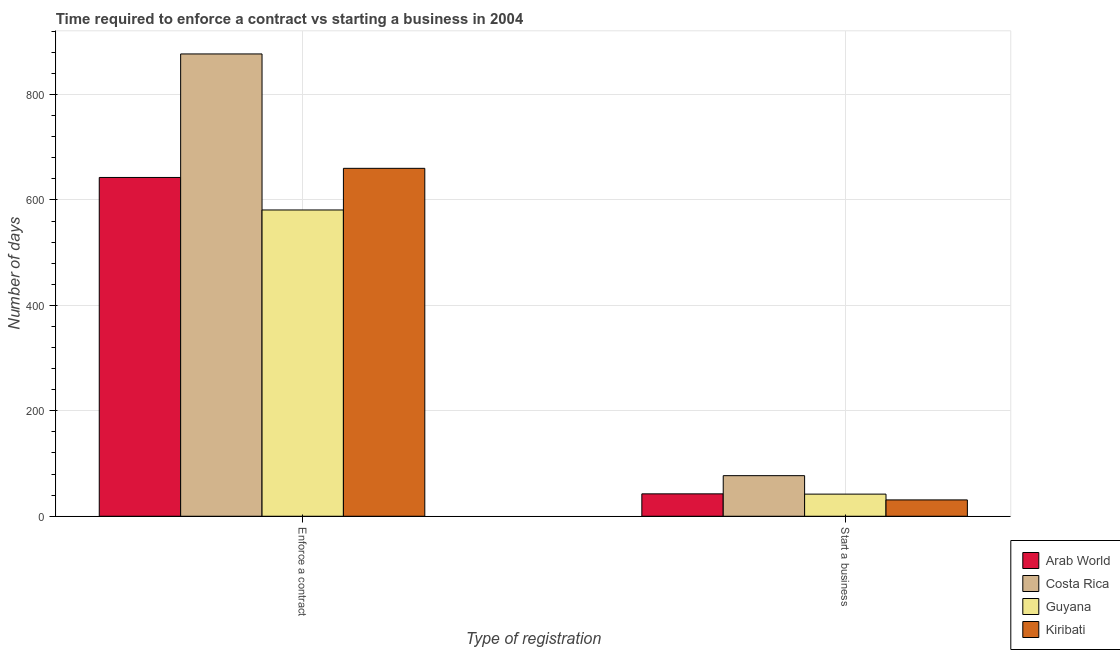How many different coloured bars are there?
Provide a short and direct response. 4. How many groups of bars are there?
Your response must be concise. 2. How many bars are there on the 1st tick from the right?
Your answer should be very brief. 4. What is the label of the 2nd group of bars from the left?
Offer a very short reply. Start a business. In which country was the number of days to enforece a contract maximum?
Your answer should be very brief. Costa Rica. In which country was the number of days to enforece a contract minimum?
Offer a terse response. Guyana. What is the total number of days to start a business in the graph?
Offer a terse response. 192.5. What is the difference between the number of days to enforece a contract in Guyana and that in Arab World?
Keep it short and to the point. -61.69. What is the difference between the number of days to enforece a contract in Costa Rica and the number of days to start a business in Arab World?
Make the answer very short. 834.5. What is the average number of days to start a business per country?
Keep it short and to the point. 48.12. What is the difference between the number of days to enforece a contract and number of days to start a business in Costa Rica?
Ensure brevity in your answer.  800. In how many countries, is the number of days to enforece a contract greater than 320 days?
Make the answer very short. 4. What is the ratio of the number of days to start a business in Kiribati to that in Costa Rica?
Keep it short and to the point. 0.4. What does the 2nd bar from the left in Enforce a contract represents?
Your answer should be compact. Costa Rica. What does the 4th bar from the right in Enforce a contract represents?
Make the answer very short. Arab World. How many bars are there?
Keep it short and to the point. 8. Are all the bars in the graph horizontal?
Your answer should be very brief. No. How many countries are there in the graph?
Offer a very short reply. 4. Are the values on the major ticks of Y-axis written in scientific E-notation?
Give a very brief answer. No. Does the graph contain any zero values?
Offer a very short reply. No. Does the graph contain grids?
Keep it short and to the point. Yes. Where does the legend appear in the graph?
Provide a succinct answer. Bottom right. What is the title of the graph?
Ensure brevity in your answer.  Time required to enforce a contract vs starting a business in 2004. What is the label or title of the X-axis?
Offer a very short reply. Type of registration. What is the label or title of the Y-axis?
Ensure brevity in your answer.  Number of days. What is the Number of days in Arab World in Enforce a contract?
Keep it short and to the point. 642.69. What is the Number of days of Costa Rica in Enforce a contract?
Your answer should be very brief. 877. What is the Number of days of Guyana in Enforce a contract?
Offer a terse response. 581. What is the Number of days in Kiribati in Enforce a contract?
Your answer should be compact. 660. What is the Number of days in Arab World in Start a business?
Ensure brevity in your answer.  42.5. What is the Number of days of Kiribati in Start a business?
Make the answer very short. 31. Across all Type of registration, what is the maximum Number of days of Arab World?
Offer a very short reply. 642.69. Across all Type of registration, what is the maximum Number of days of Costa Rica?
Ensure brevity in your answer.  877. Across all Type of registration, what is the maximum Number of days of Guyana?
Offer a very short reply. 581. Across all Type of registration, what is the maximum Number of days in Kiribati?
Keep it short and to the point. 660. Across all Type of registration, what is the minimum Number of days of Arab World?
Give a very brief answer. 42.5. Across all Type of registration, what is the minimum Number of days of Kiribati?
Give a very brief answer. 31. What is the total Number of days of Arab World in the graph?
Give a very brief answer. 685.19. What is the total Number of days in Costa Rica in the graph?
Provide a succinct answer. 954. What is the total Number of days of Guyana in the graph?
Your response must be concise. 623. What is the total Number of days of Kiribati in the graph?
Keep it short and to the point. 691. What is the difference between the Number of days in Arab World in Enforce a contract and that in Start a business?
Make the answer very short. 600.19. What is the difference between the Number of days in Costa Rica in Enforce a contract and that in Start a business?
Give a very brief answer. 800. What is the difference between the Number of days of Guyana in Enforce a contract and that in Start a business?
Make the answer very short. 539. What is the difference between the Number of days of Kiribati in Enforce a contract and that in Start a business?
Offer a very short reply. 629. What is the difference between the Number of days in Arab World in Enforce a contract and the Number of days in Costa Rica in Start a business?
Your answer should be compact. 565.69. What is the difference between the Number of days in Arab World in Enforce a contract and the Number of days in Guyana in Start a business?
Your response must be concise. 600.69. What is the difference between the Number of days of Arab World in Enforce a contract and the Number of days of Kiribati in Start a business?
Your response must be concise. 611.69. What is the difference between the Number of days of Costa Rica in Enforce a contract and the Number of days of Guyana in Start a business?
Provide a succinct answer. 835. What is the difference between the Number of days in Costa Rica in Enforce a contract and the Number of days in Kiribati in Start a business?
Your answer should be very brief. 846. What is the difference between the Number of days in Guyana in Enforce a contract and the Number of days in Kiribati in Start a business?
Make the answer very short. 550. What is the average Number of days of Arab World per Type of registration?
Make the answer very short. 342.59. What is the average Number of days of Costa Rica per Type of registration?
Give a very brief answer. 477. What is the average Number of days of Guyana per Type of registration?
Offer a very short reply. 311.5. What is the average Number of days of Kiribati per Type of registration?
Make the answer very short. 345.5. What is the difference between the Number of days in Arab World and Number of days in Costa Rica in Enforce a contract?
Give a very brief answer. -234.31. What is the difference between the Number of days of Arab World and Number of days of Guyana in Enforce a contract?
Keep it short and to the point. 61.69. What is the difference between the Number of days in Arab World and Number of days in Kiribati in Enforce a contract?
Your answer should be very brief. -17.31. What is the difference between the Number of days in Costa Rica and Number of days in Guyana in Enforce a contract?
Offer a terse response. 296. What is the difference between the Number of days of Costa Rica and Number of days of Kiribati in Enforce a contract?
Your answer should be compact. 217. What is the difference between the Number of days in Guyana and Number of days in Kiribati in Enforce a contract?
Make the answer very short. -79. What is the difference between the Number of days of Arab World and Number of days of Costa Rica in Start a business?
Offer a very short reply. -34.5. What is the difference between the Number of days in Arab World and Number of days in Kiribati in Start a business?
Your answer should be very brief. 11.5. What is the ratio of the Number of days of Arab World in Enforce a contract to that in Start a business?
Ensure brevity in your answer.  15.12. What is the ratio of the Number of days of Costa Rica in Enforce a contract to that in Start a business?
Your response must be concise. 11.39. What is the ratio of the Number of days of Guyana in Enforce a contract to that in Start a business?
Provide a succinct answer. 13.83. What is the ratio of the Number of days in Kiribati in Enforce a contract to that in Start a business?
Ensure brevity in your answer.  21.29. What is the difference between the highest and the second highest Number of days in Arab World?
Provide a succinct answer. 600.19. What is the difference between the highest and the second highest Number of days of Costa Rica?
Keep it short and to the point. 800. What is the difference between the highest and the second highest Number of days in Guyana?
Provide a short and direct response. 539. What is the difference between the highest and the second highest Number of days of Kiribati?
Make the answer very short. 629. What is the difference between the highest and the lowest Number of days in Arab World?
Give a very brief answer. 600.19. What is the difference between the highest and the lowest Number of days in Costa Rica?
Give a very brief answer. 800. What is the difference between the highest and the lowest Number of days of Guyana?
Your answer should be compact. 539. What is the difference between the highest and the lowest Number of days in Kiribati?
Your answer should be compact. 629. 